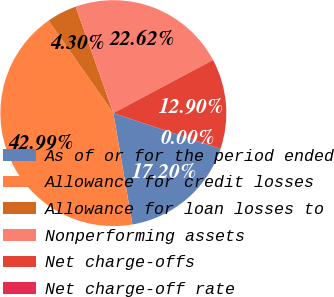Convert chart. <chart><loc_0><loc_0><loc_500><loc_500><pie_chart><fcel>As of or for the period ended<fcel>Allowance for credit losses<fcel>Allowance for loan losses to<fcel>Nonperforming assets<fcel>Net charge-offs<fcel>Net charge-off rate<nl><fcel>17.2%<fcel>42.99%<fcel>4.3%<fcel>22.62%<fcel>12.9%<fcel>0.0%<nl></chart> 